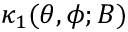Convert formula to latex. <formula><loc_0><loc_0><loc_500><loc_500>\kappa _ { 1 } ( \theta , \phi ; B )</formula> 